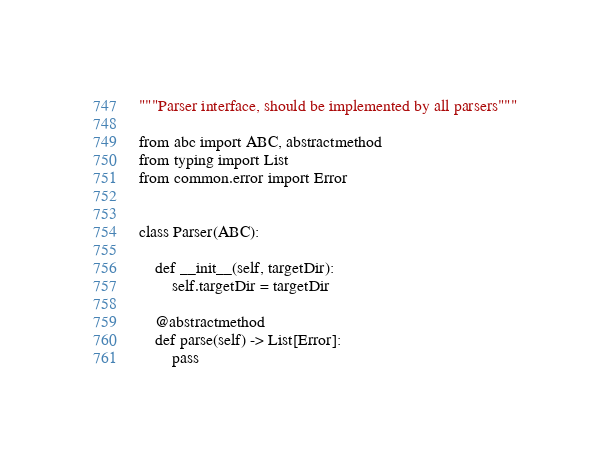Convert code to text. <code><loc_0><loc_0><loc_500><loc_500><_Python_>"""Parser interface, should be implemented by all parsers"""

from abc import ABC, abstractmethod
from typing import List
from common.error import Error


class Parser(ABC):

    def __init__(self, targetDir):
        self.targetDir = targetDir

    @abstractmethod
    def parse(self) -> List[Error]:
        pass
</code> 